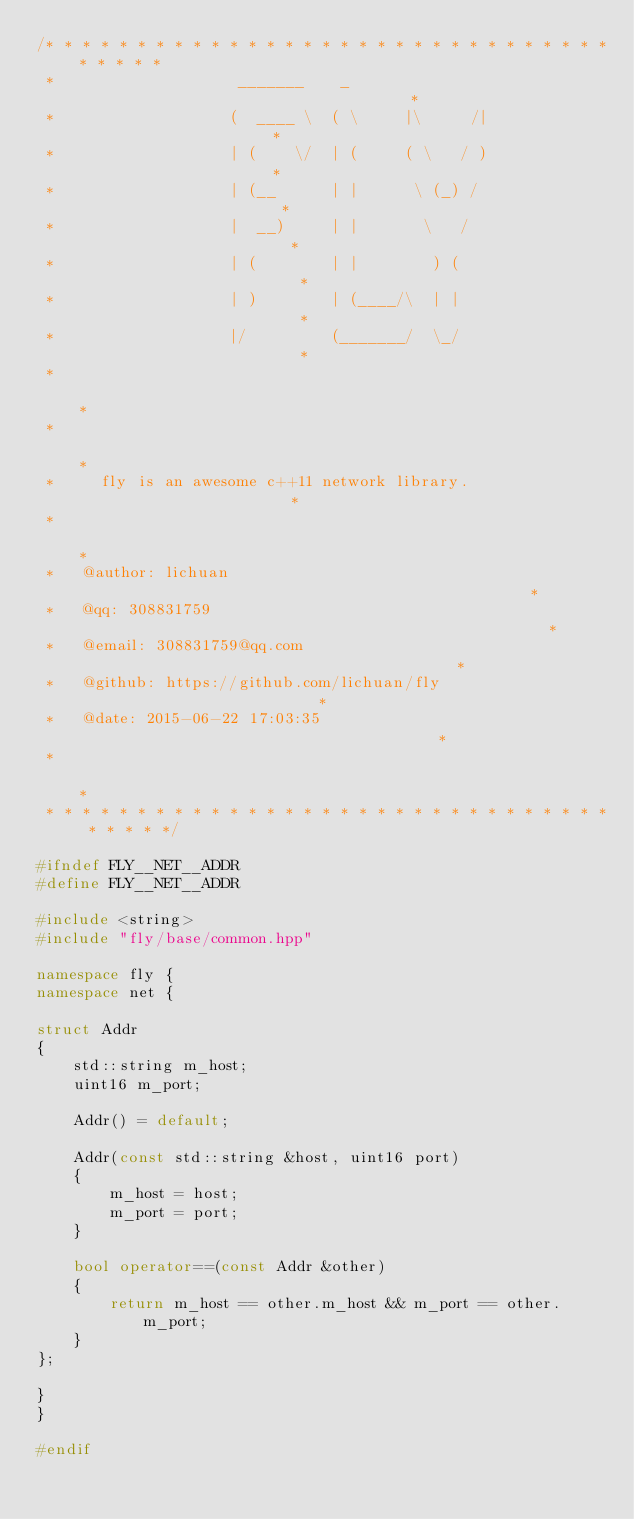Convert code to text. <code><loc_0><loc_0><loc_500><loc_500><_C++_>/* * * * * * * * * * * * * * * * * * * * * * * * * * * * * * * * * * * *
 *                    _______    _                                     *
 *                   (  ____ \  ( \     |\     /|                      * 
 *                   | (    \/  | (     ( \   / )                      *
 *                   | (__      | |      \ (_) /                       *
 *                   |  __)     | |       \   /                        *
 *                   | (        | |        ) (                         *
 *                   | )        | (____/\  | |                         *
 *                   |/         (_______/  \_/                         *
 *                                                                     *
 *                                                                     *
 *     fly is an awesome c++11 network library.                        *
 *                                                                     *
 *   @author: lichuan                                                  *
 *   @qq: 308831759                                                    *
 *   @email: 308831759@qq.com                                          *
 *   @github: https://github.com/lichuan/fly                           *
 *   @date: 2015-06-22 17:03:35                                        *
 *                                                                     *
 * * * * * * * * * * * * * * * * * * * * * * * * * * * * * * * * * * * */

#ifndef FLY__NET__ADDR
#define FLY__NET__ADDR

#include <string>
#include "fly/base/common.hpp"

namespace fly {
namespace net {

struct Addr
{
    std::string m_host;
    uint16 m_port;

    Addr() = default;

    Addr(const std::string &host, uint16 port)
    {
        m_host = host;
        m_port = port;
    }

    bool operator==(const Addr &other)
    {
        return m_host == other.m_host && m_port == other.m_port;
    }
};

}
}

#endif
</code> 